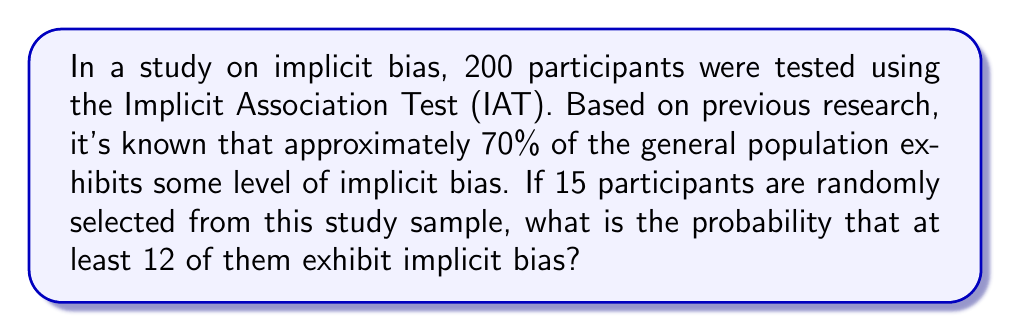Show me your answer to this math problem. To solve this problem, we need to use the binomial probability distribution and the concept of cumulative probability. Let's break it down step by step:

1) First, let's define our variables:
   $n = 15$ (number of participants selected)
   $p = 0.70$ (probability of exhibiting implicit bias)
   $q = 1 - p = 0.30$ (probability of not exhibiting implicit bias)

2) We want to find the probability of at least 12 participants exhibiting bias. This means we need to calculate:
   $P(X \geq 12) = P(X = 12) + P(X = 13) + P(X = 14) + P(X = 15)$

3) We can use the binomial probability formula for each of these:
   $P(X = k) = \binom{n}{k} p^k q^{n-k}$

4) Let's calculate each probability:

   $P(X = 12) = \binom{15}{12} (0.70)^{12} (0.30)^3 = 0.1662$
   
   $P(X = 13) = \binom{15}{13} (0.70)^{13} (0.30)^2 = 0.0712$
   
   $P(X = 14) = \binom{15}{14} (0.70)^{14} (0.30)^1 = 0.0153$
   
   $P(X = 15) = \binom{15}{15} (0.70)^{15} (0.30)^0 = 0.0013$

5) Now, we sum these probabilities:

   $P(X \geq 12) = 0.1662 + 0.0712 + 0.0153 + 0.0013 = 0.2540$

Therefore, the probability that at least 12 out of 15 randomly selected participants exhibit implicit bias is approximately 0.2540 or 25.40%.
Answer: 0.2540 or 25.40% 